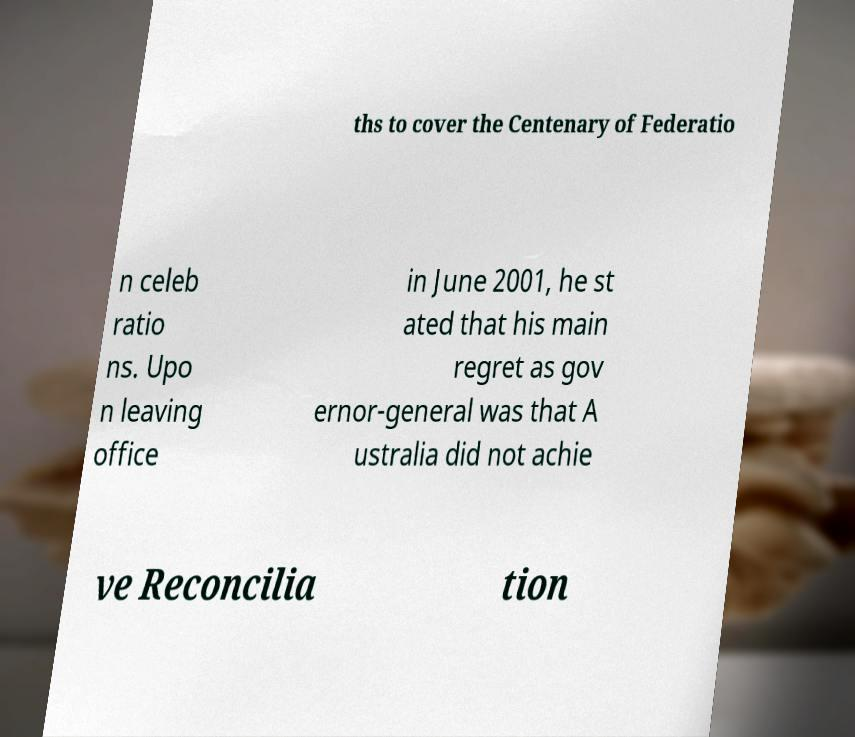For documentation purposes, I need the text within this image transcribed. Could you provide that? ths to cover the Centenary of Federatio n celeb ratio ns. Upo n leaving office in June 2001, he st ated that his main regret as gov ernor-general was that A ustralia did not achie ve Reconcilia tion 